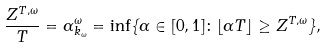Convert formula to latex. <formula><loc_0><loc_0><loc_500><loc_500>\frac { Z ^ { T , \omega } } { T } = \alpha ^ { \omega } _ { k _ { \omega } } = \inf \{ \alpha \in [ 0 , 1 ] \colon \lfloor \alpha T \rfloor \geq Z ^ { T , \omega } \} ,</formula> 